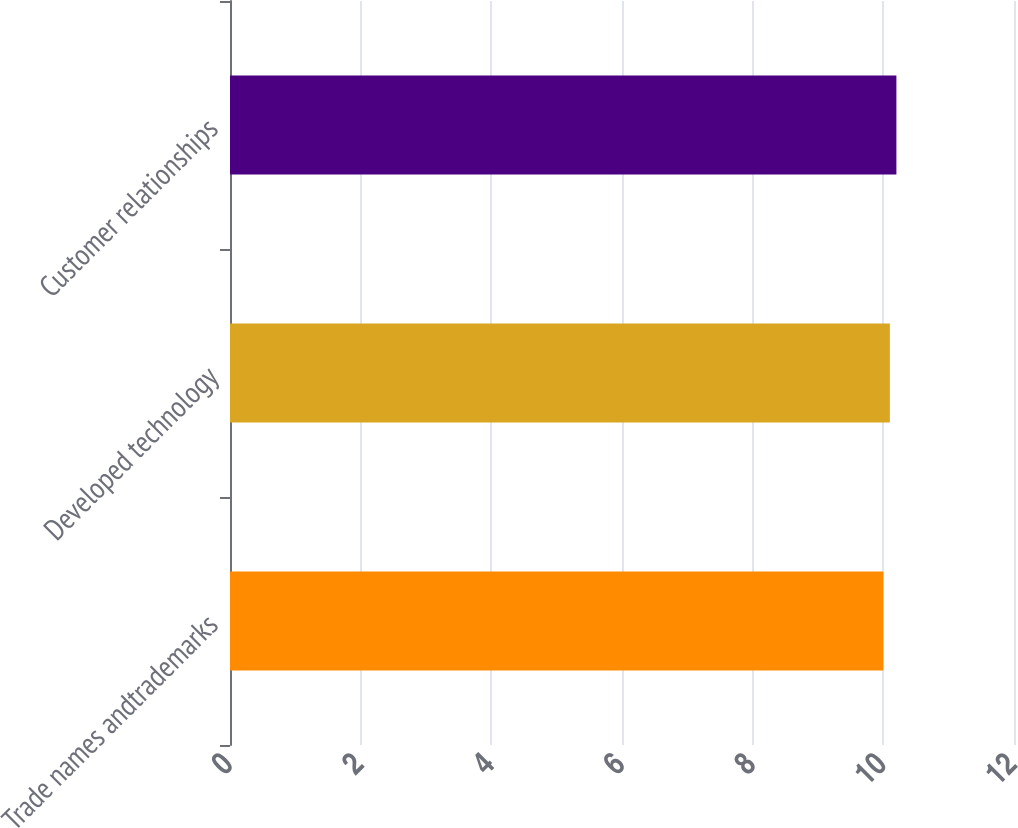Convert chart. <chart><loc_0><loc_0><loc_500><loc_500><bar_chart><fcel>Trade names andtrademarks<fcel>Developed technology<fcel>Customer relationships<nl><fcel>10<fcel>10.1<fcel>10.2<nl></chart> 